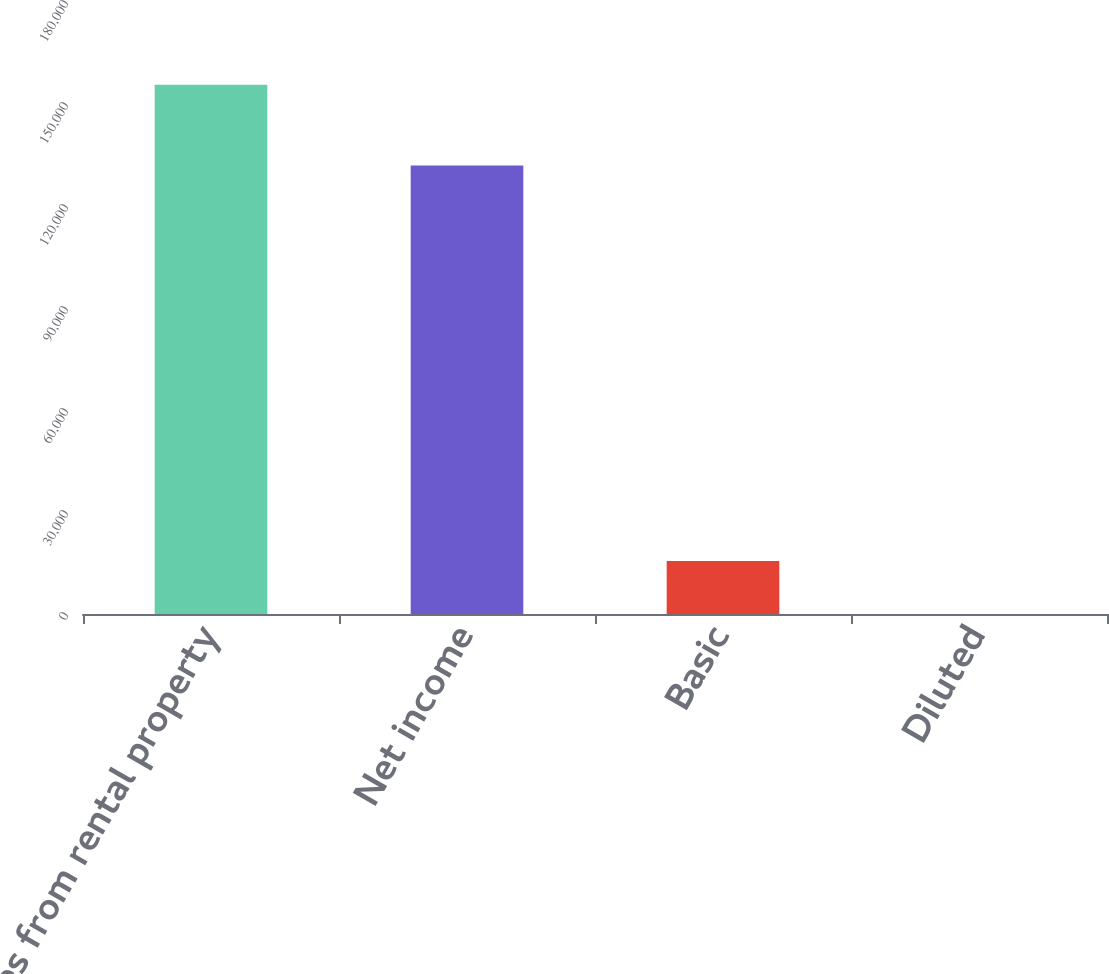<chart> <loc_0><loc_0><loc_500><loc_500><bar_chart><fcel>Revenues from rental property<fcel>Net income<fcel>Basic<fcel>Diluted<nl><fcel>155678<fcel>131899<fcel>15568.3<fcel>0.51<nl></chart> 